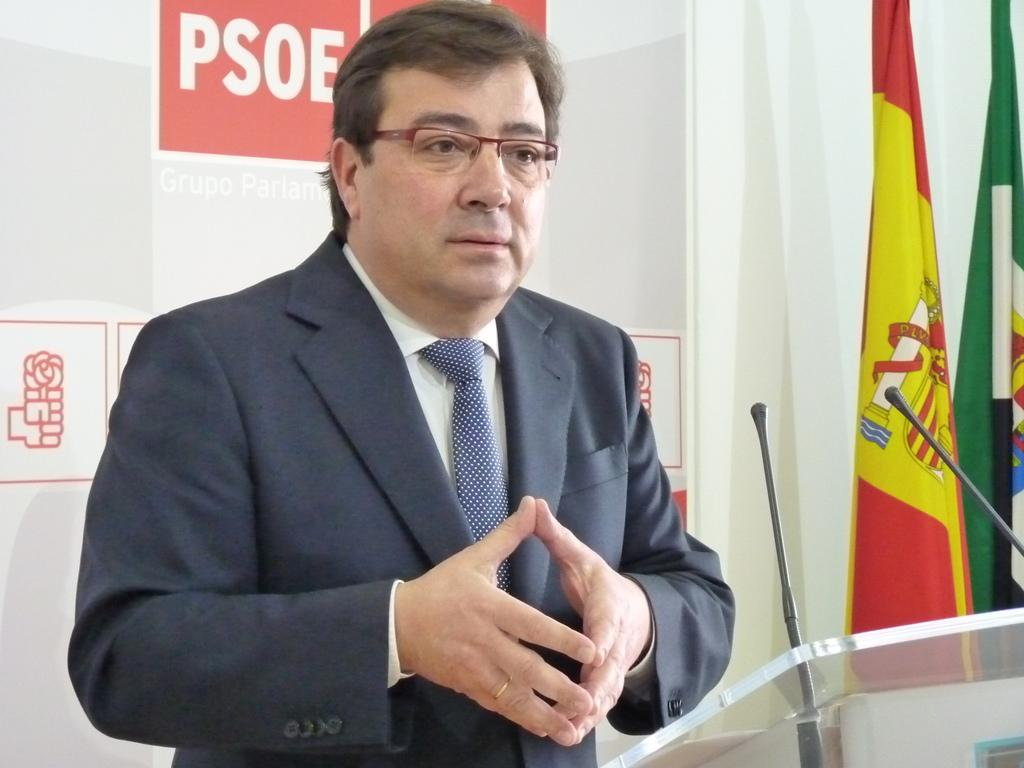What is the person in the image doing? There is a person standing at a desk in the image. What can be seen on the right side of the image? There are flags on the right side of the image. What is visible in the background of the image? There is a wall in the background of the image. How many ladybugs can be seen on the person's shoulder in the image? There are no ladybugs visible on the person's shoulder in the image. 